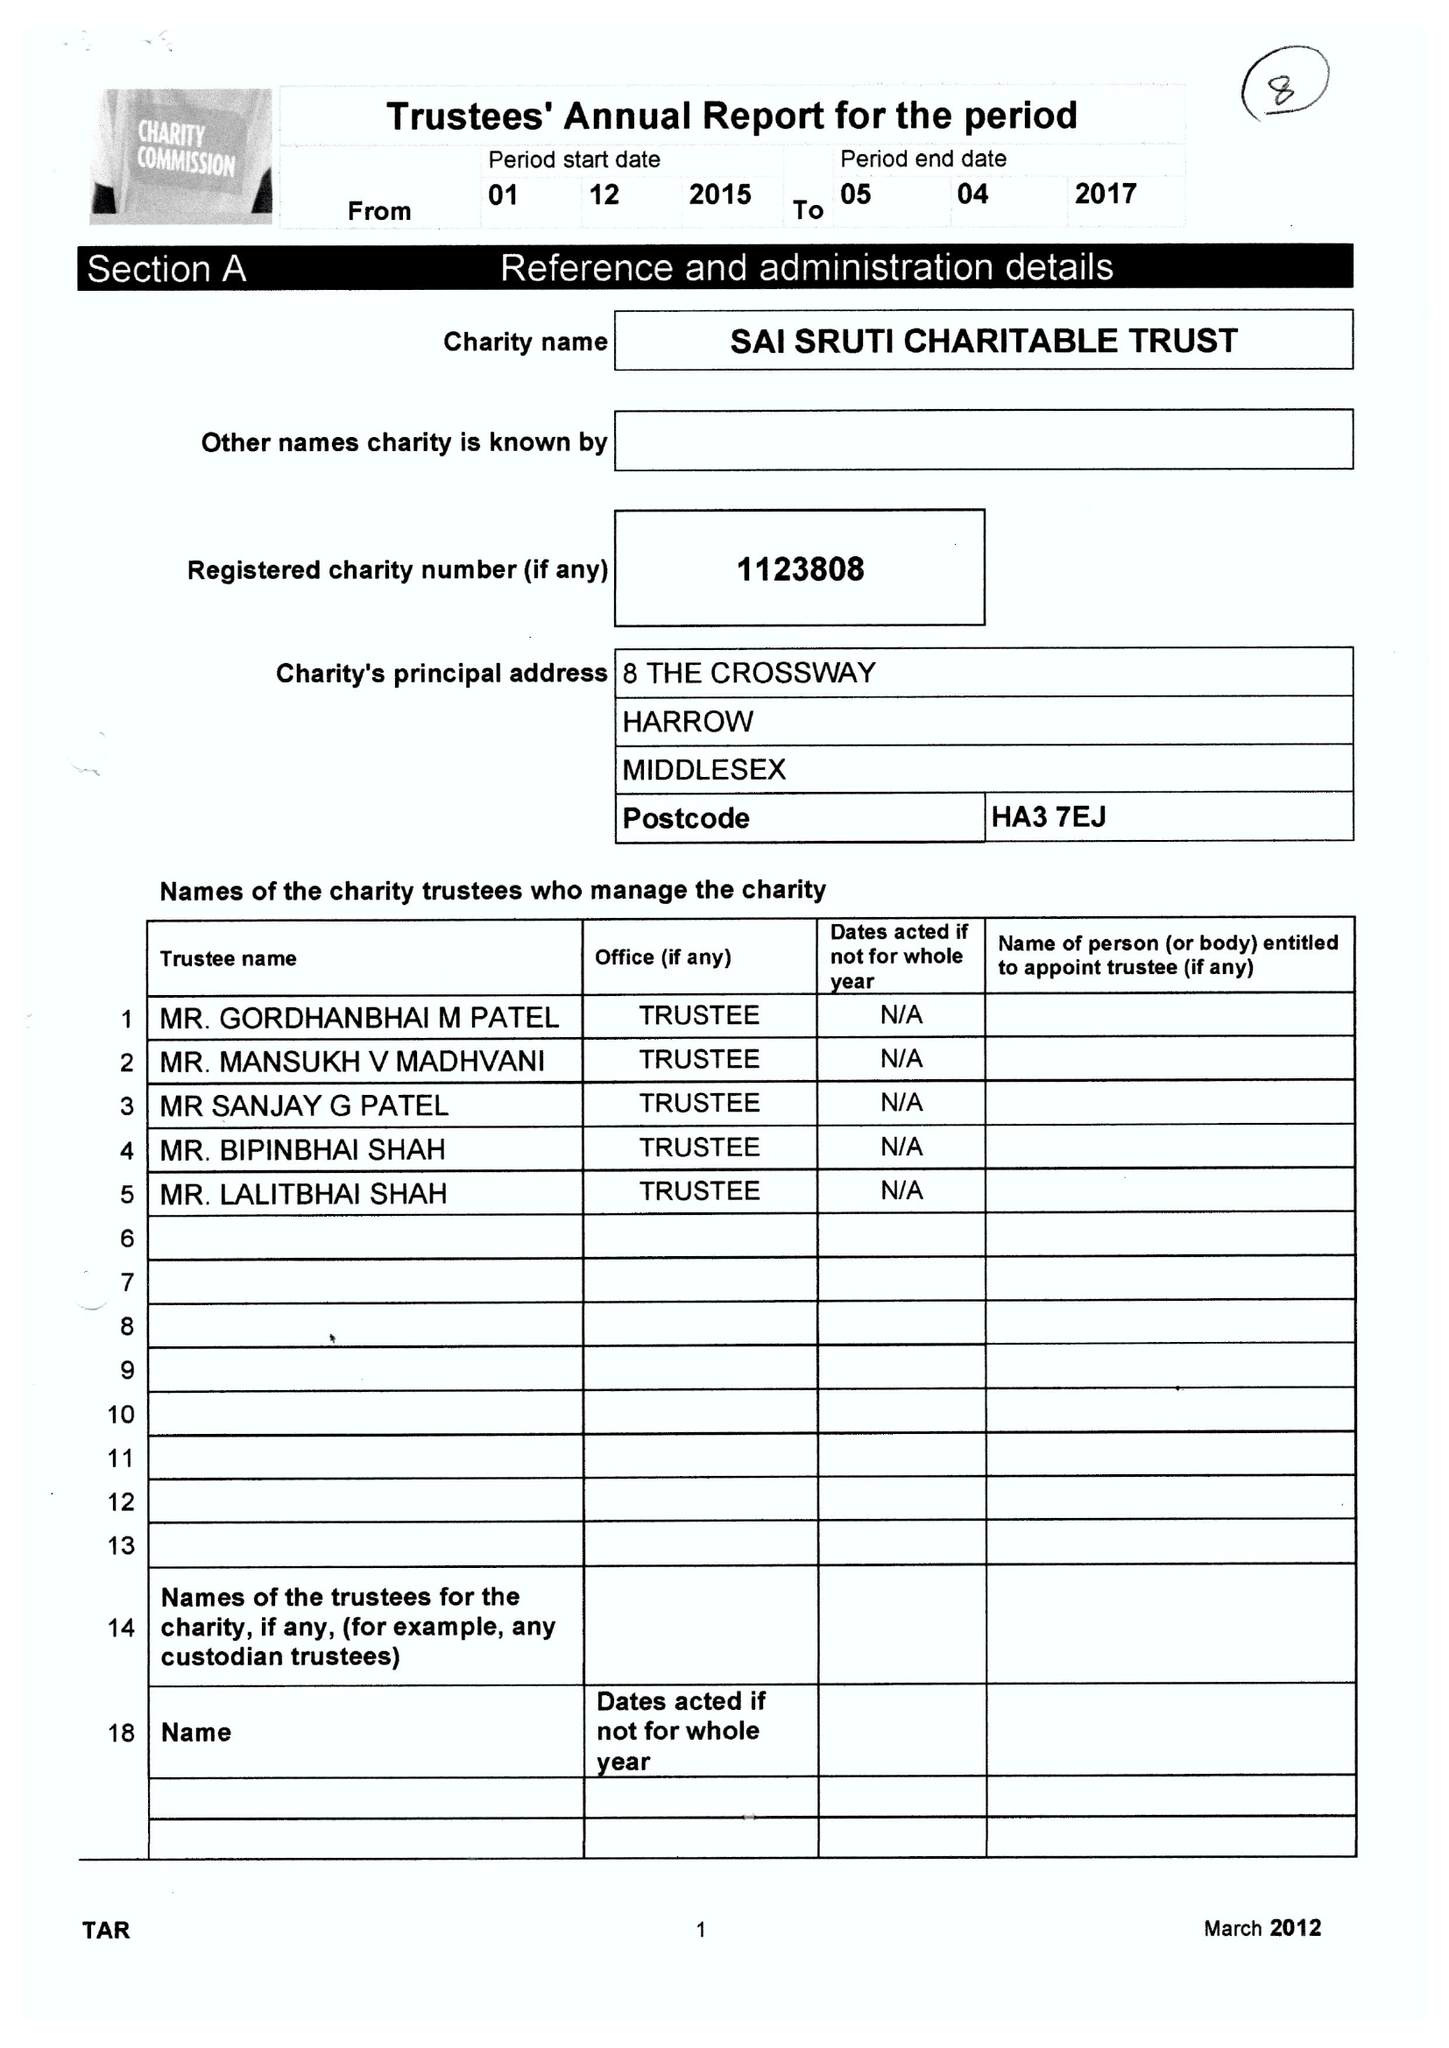What is the value for the address__postcode?
Answer the question using a single word or phrase. HA3 7EJ 